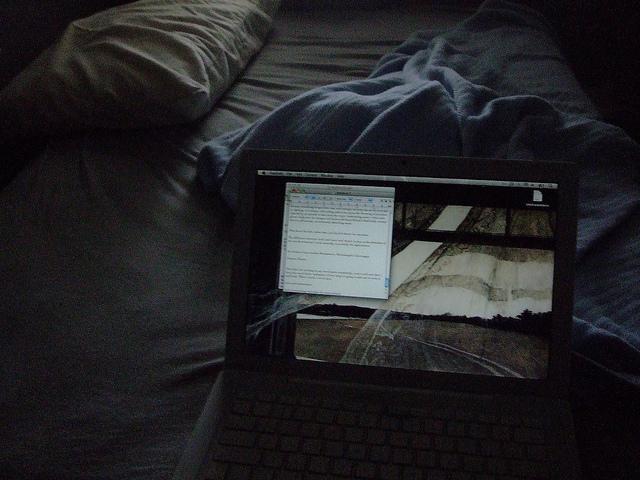How many of the giraffes have their butts directly facing the camera?
Give a very brief answer. 0. 